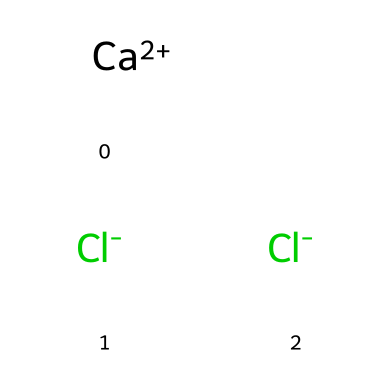What is the molecular formula of this chemical? The SMILES representation shows one calcium atom and two chlorine atoms. The total formula can be assembled from the symbols, which leads to CaCl2.
Answer: CaCl2 How many chlorine atoms are present in the structure? The SMILES indicates two Cl- symbols, which represents two chlorine atoms, confirming their count in the chemical structure.
Answer: 2 What is the oxidation state of calcium in this compound? In the SMILES, the calcium atom appears as Ca+2, indicating it has a +2 oxidation state. This happens because calcium typically loses two electrons to achieve stability.
Answer: +2 Is this compound ionic or covalent? The presence of charged ions (Ca+2 and Cl-) indicates that this compound forms ionic bonds, common in salts where electrons are transferred rather than shared.
Answer: ionic What type of ions does this chemical contain? The SMILES notation includes a positive calcium ion and negative chloride ions, which are characteristic of cations and anions in salts.
Answer: cations and anions Can this chemical be classified as a fungicide? Calcium chloride is primarily known for its use in de-icing and moisture control rather than as a fungicide, as it does not specifically target fungi.
Answer: No 